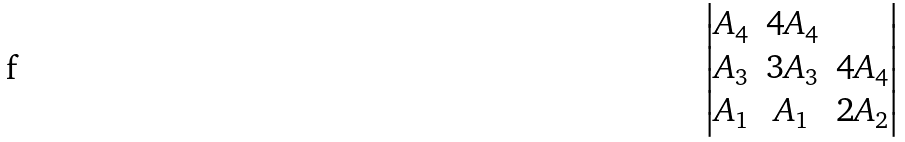Convert formula to latex. <formula><loc_0><loc_0><loc_500><loc_500>\begin{vmatrix} A _ { 4 } & 4 A _ { 4 } & \\ A _ { 3 } & 3 A _ { 3 } & 4 A _ { 4 } \\ A _ { 1 } & A _ { 1 } & 2 A _ { 2 } \\ \end{vmatrix}</formula> 